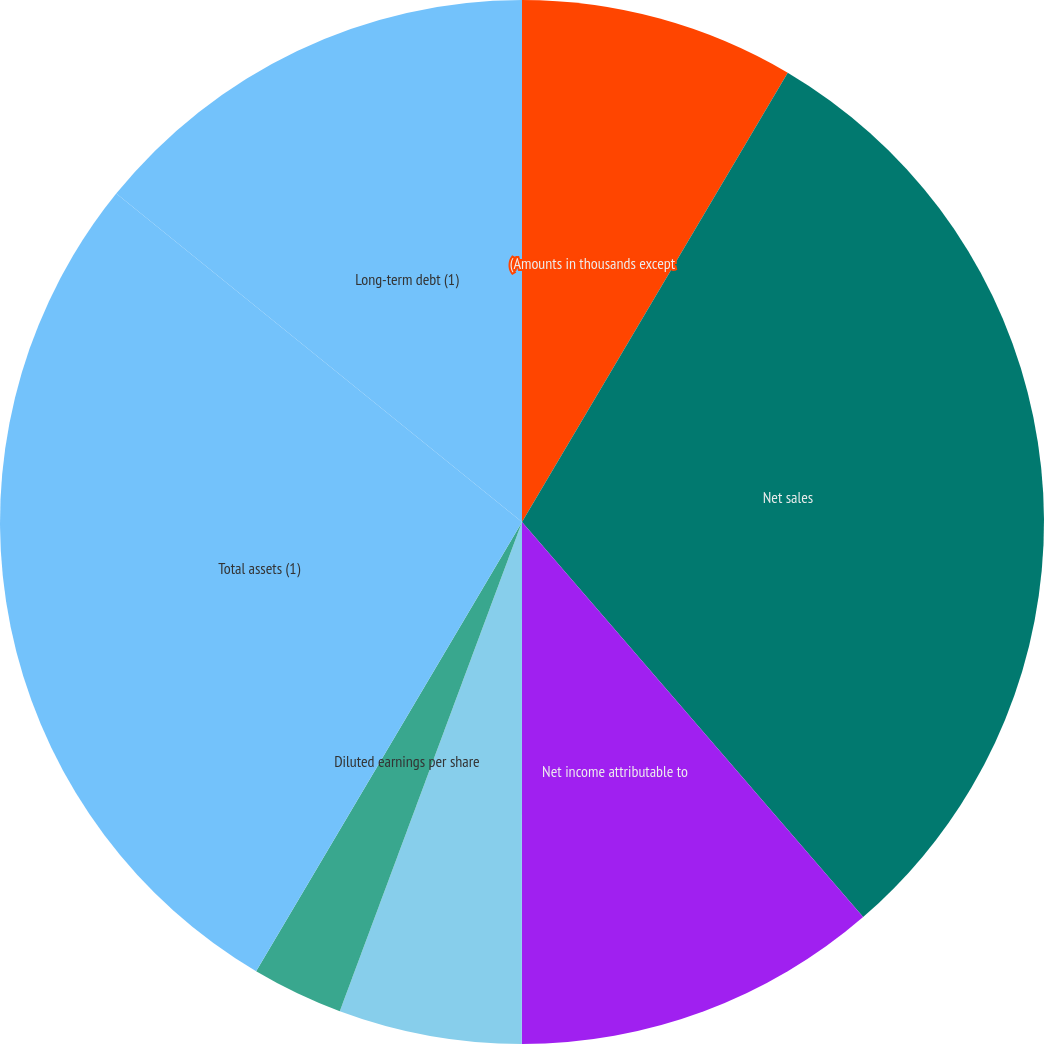<chart> <loc_0><loc_0><loc_500><loc_500><pie_chart><fcel>(Amounts in thousands except<fcel>Net sales<fcel>Net income attributable to<fcel>Basic earnings per share<fcel>Diluted earnings per share<fcel>Cash dividends per share<fcel>Total assets (1)<fcel>Long-term debt (1)<nl><fcel>8.5%<fcel>30.16%<fcel>11.34%<fcel>5.67%<fcel>2.83%<fcel>0.0%<fcel>27.32%<fcel>14.17%<nl></chart> 